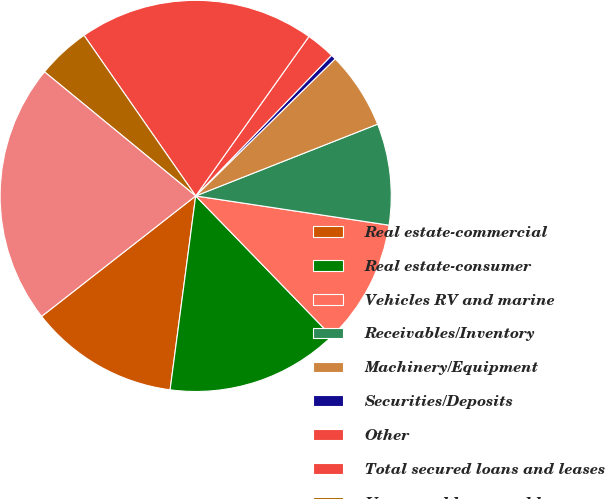Convert chart to OTSL. <chart><loc_0><loc_0><loc_500><loc_500><pie_chart><fcel>Real estate-commercial<fcel>Real estate-consumer<fcel>Vehicles RV and marine<fcel>Receivables/Inventory<fcel>Machinery/Equipment<fcel>Securities/Deposits<fcel>Other<fcel>Total secured loans and leases<fcel>Unsecured loans and leases<fcel>Total loans and leases<nl><fcel>12.35%<fcel>14.34%<fcel>10.36%<fcel>8.37%<fcel>6.38%<fcel>0.41%<fcel>2.4%<fcel>19.5%<fcel>4.39%<fcel>21.5%<nl></chart> 